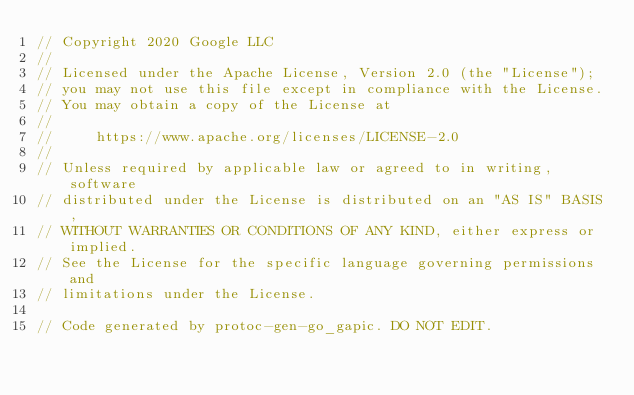<code> <loc_0><loc_0><loc_500><loc_500><_Go_>// Copyright 2020 Google LLC
//
// Licensed under the Apache License, Version 2.0 (the "License");
// you may not use this file except in compliance with the License.
// You may obtain a copy of the License at
//
//     https://www.apache.org/licenses/LICENSE-2.0
//
// Unless required by applicable law or agreed to in writing, software
// distributed under the License is distributed on an "AS IS" BASIS,
// WITHOUT WARRANTIES OR CONDITIONS OF ANY KIND, either express or implied.
// See the License for the specific language governing permissions and
// limitations under the License.

// Code generated by protoc-gen-go_gapic. DO NOT EDIT.
</code> 